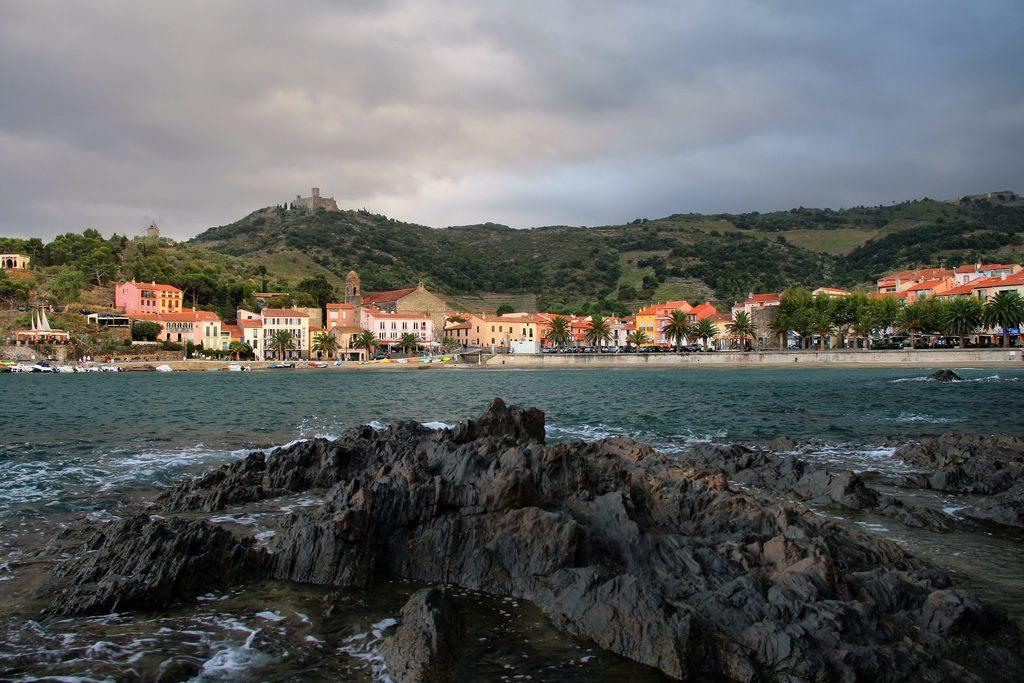What type of structures can be seen in the image? There are buildings in the image. What architectural features can be observed on the buildings? Windows are visible in the image. What natural elements are present in the image? There are trees and water in the image. What type of fort is depicted in the image? There is a fort in the image. What geological features can be seen in the image? Rocks are present in the image. What other objects can be seen in the image? There are other objects in the image. What can be seen in the sky in the image? The sky is visible in the image. Where is the van parked in the image? There is no van present in the image. What type of rabbit can be seen hopping near the trees in the image? There are no rabbits present in the image. 